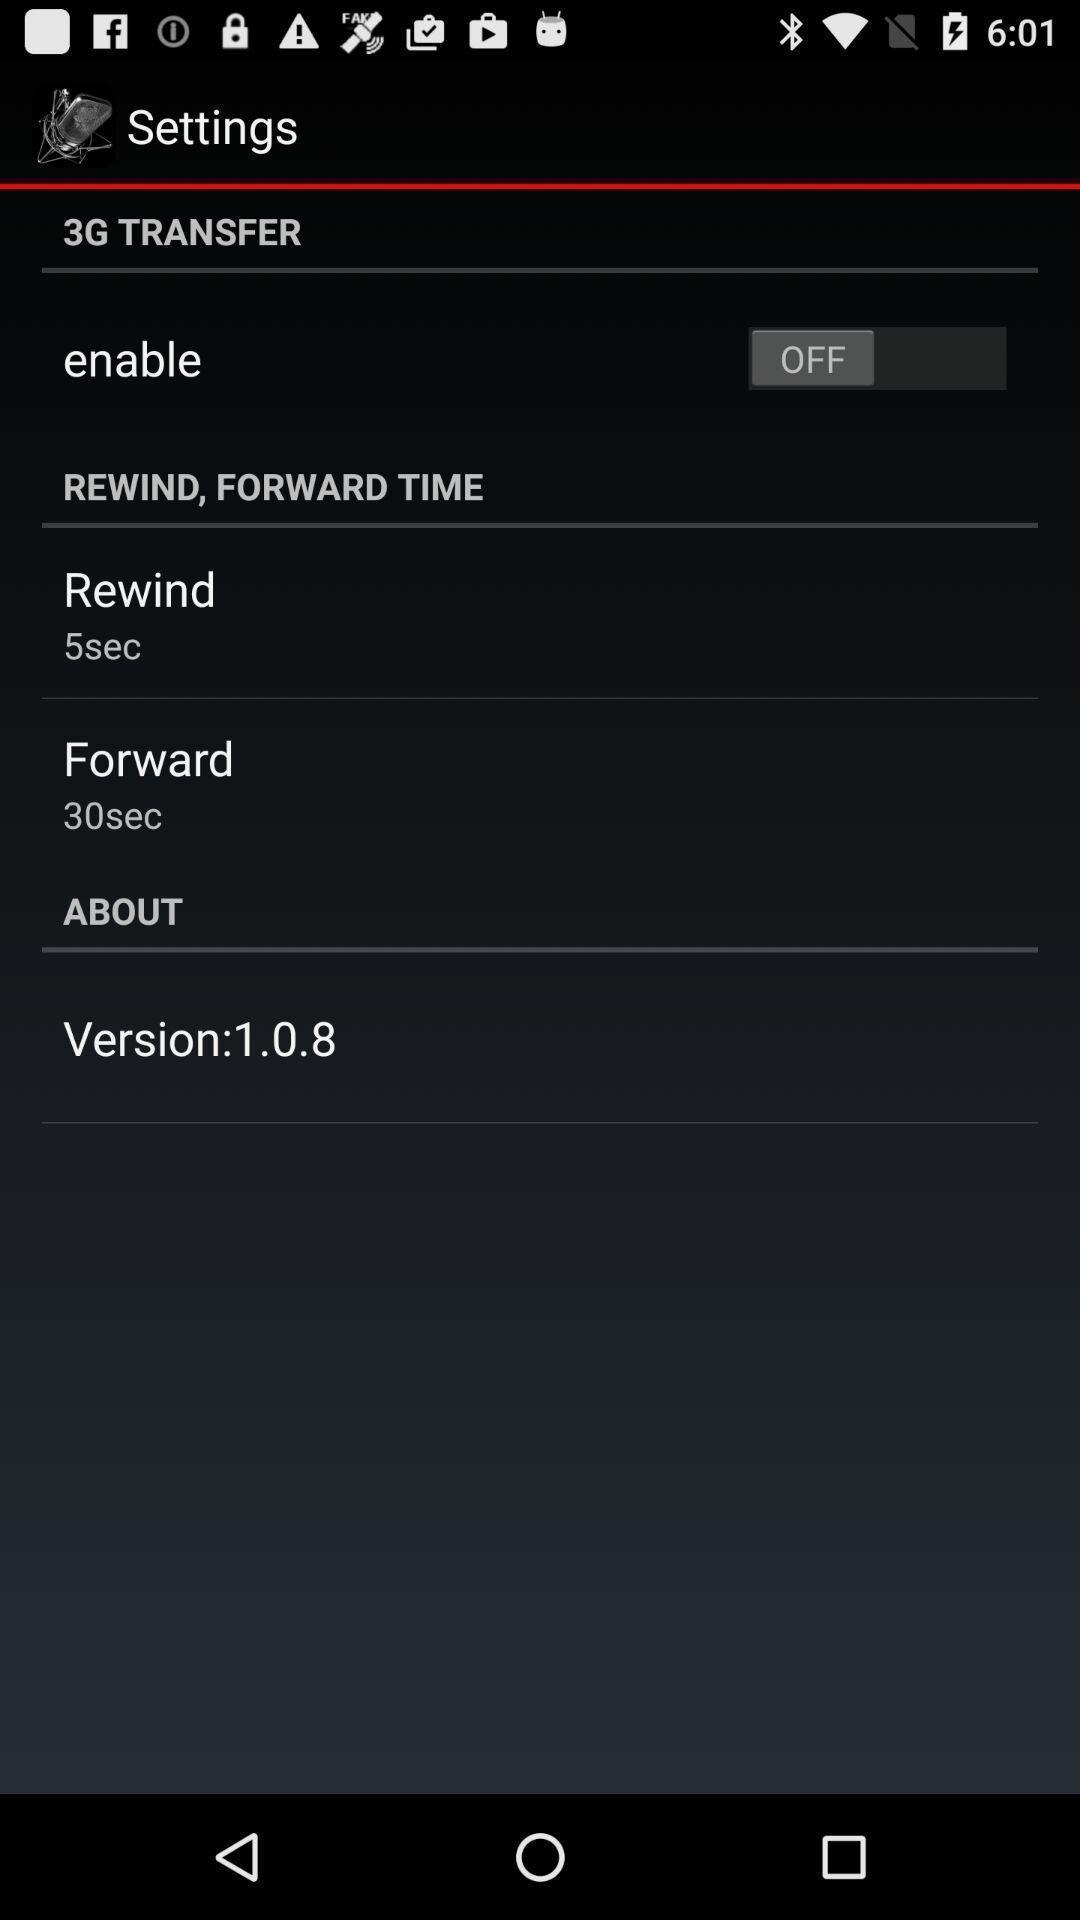Provide a textual representation of this image. Settings page of voice recording application. 